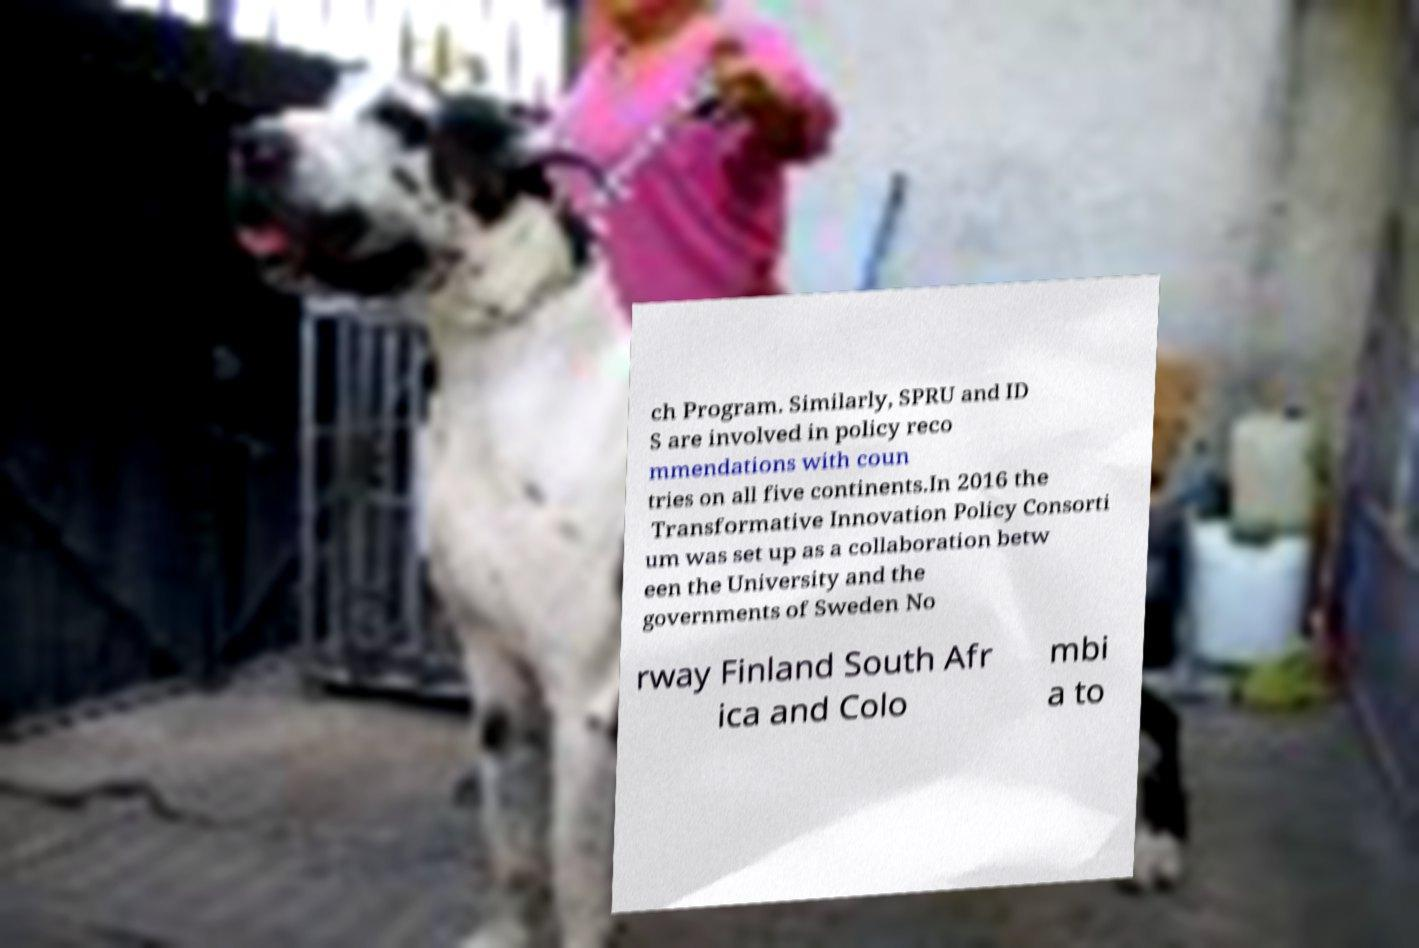Can you read and provide the text displayed in the image?This photo seems to have some interesting text. Can you extract and type it out for me? ch Program. Similarly, SPRU and ID S are involved in policy reco mmendations with coun tries on all five continents.In 2016 the Transformative Innovation Policy Consorti um was set up as a collaboration betw een the University and the governments of Sweden No rway Finland South Afr ica and Colo mbi a to 